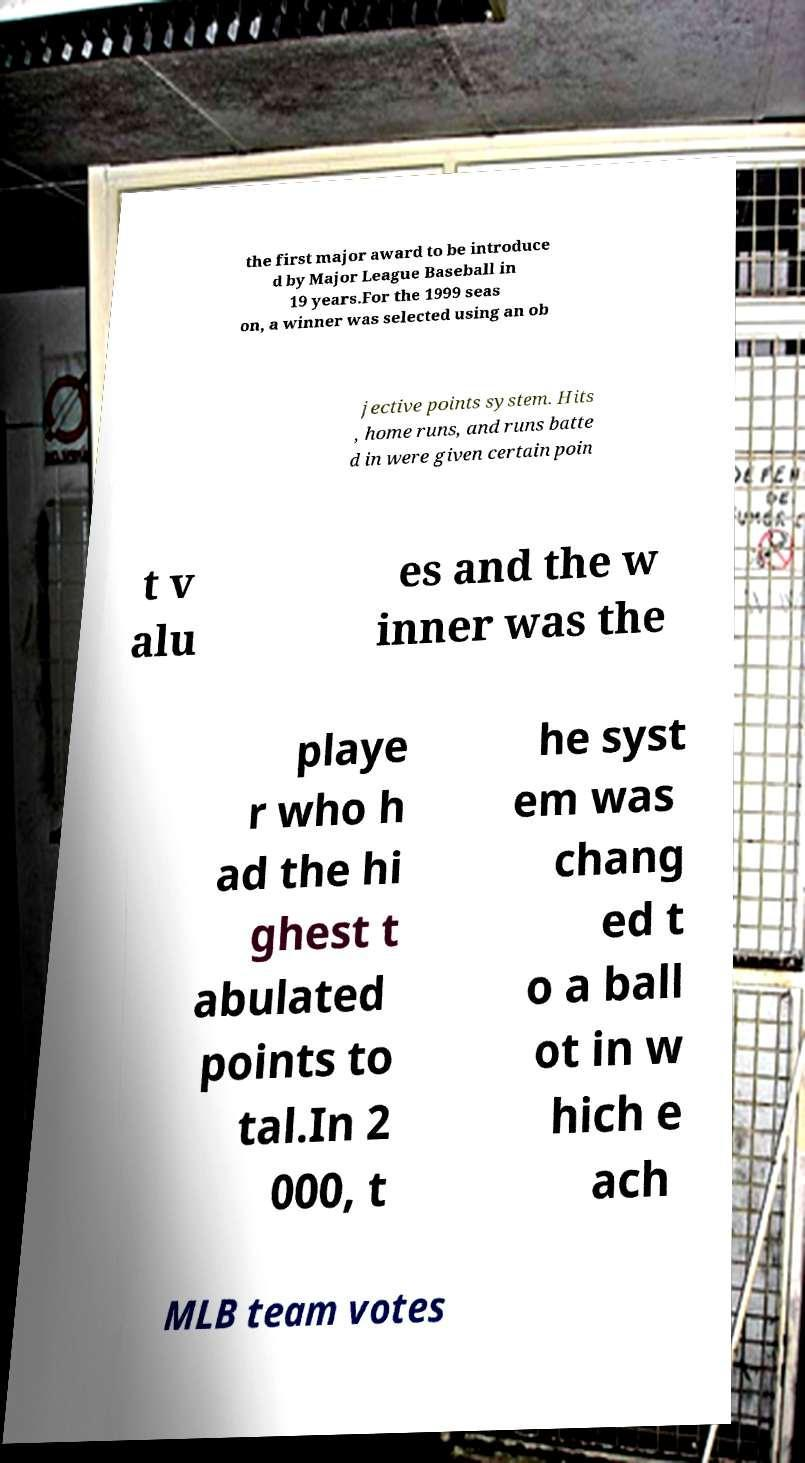I need the written content from this picture converted into text. Can you do that? the first major award to be introduce d by Major League Baseball in 19 years.For the 1999 seas on, a winner was selected using an ob jective points system. Hits , home runs, and runs batte d in were given certain poin t v alu es and the w inner was the playe r who h ad the hi ghest t abulated points to tal.In 2 000, t he syst em was chang ed t o a ball ot in w hich e ach MLB team votes 